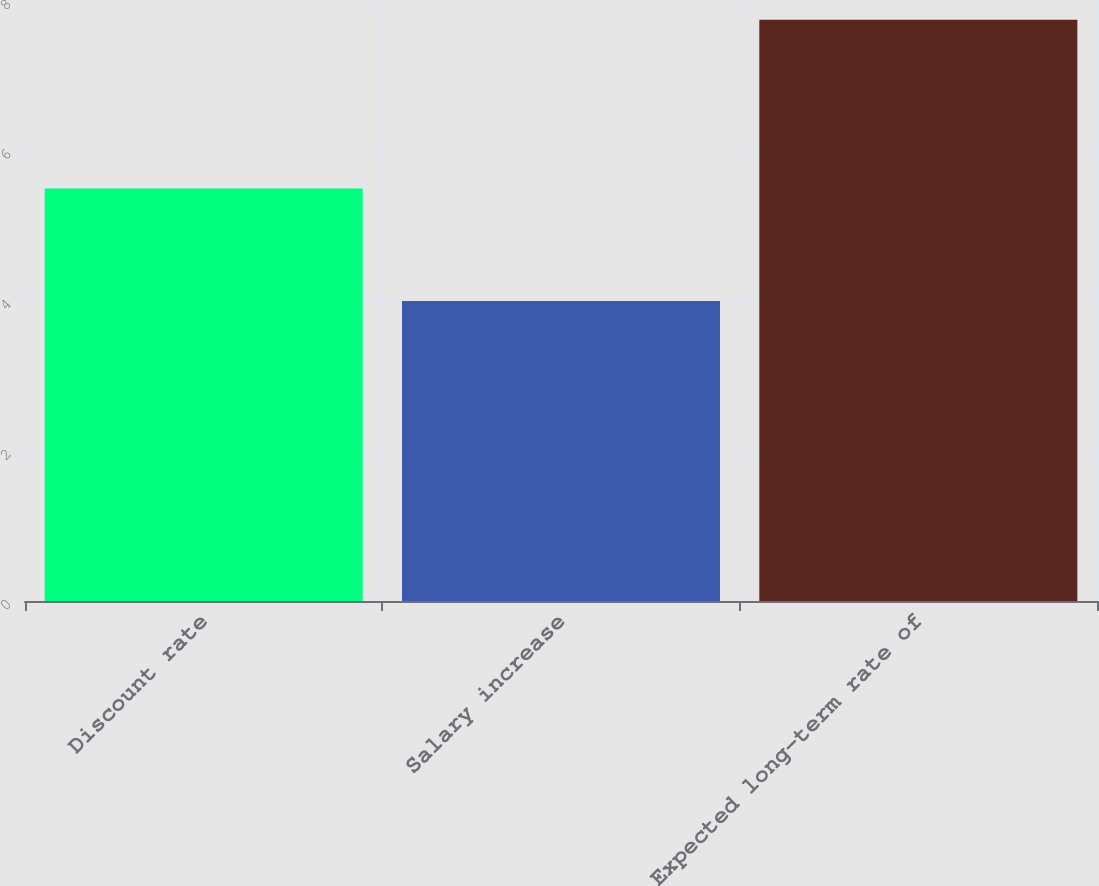Convert chart. <chart><loc_0><loc_0><loc_500><loc_500><bar_chart><fcel>Discount rate<fcel>Salary increase<fcel>Expected long-term rate of<nl><fcel>5.5<fcel>4<fcel>7.75<nl></chart> 